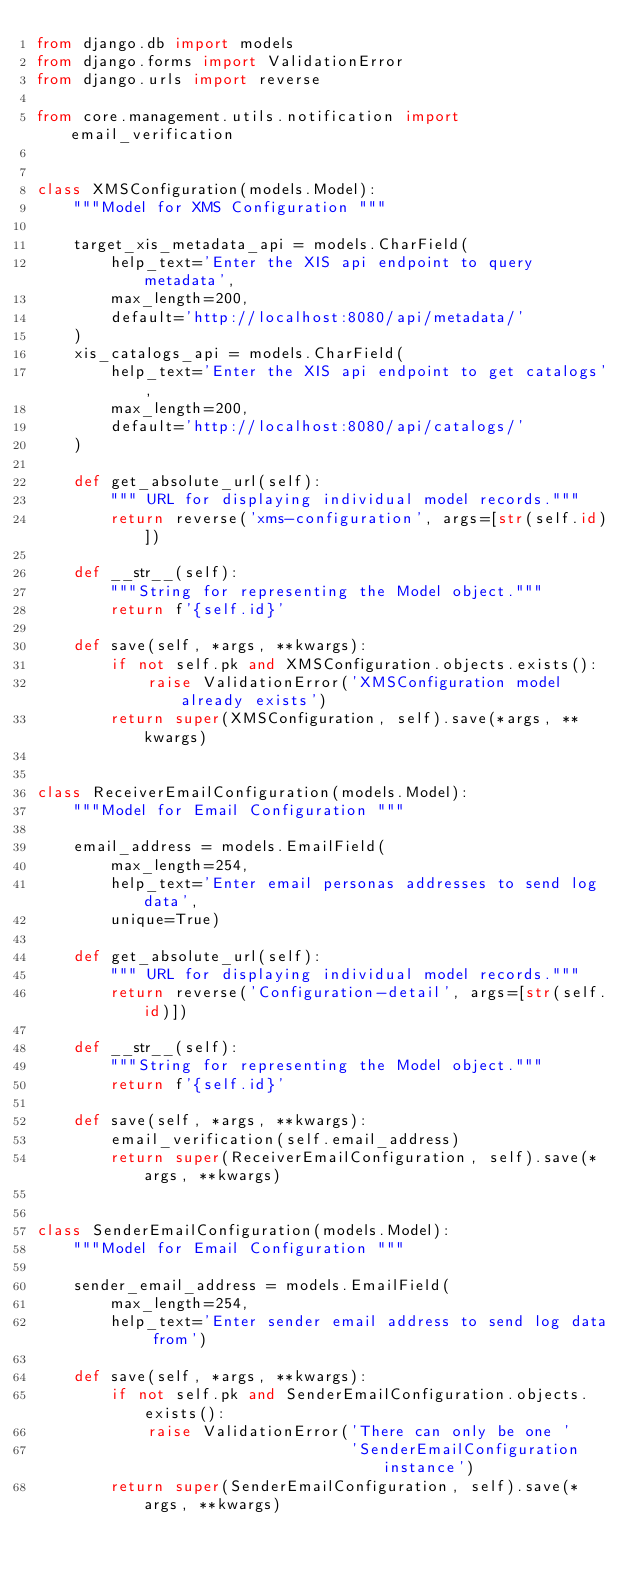Convert code to text. <code><loc_0><loc_0><loc_500><loc_500><_Python_>from django.db import models
from django.forms import ValidationError
from django.urls import reverse

from core.management.utils.notification import email_verification


class XMSConfiguration(models.Model):
    """Model for XMS Configuration """

    target_xis_metadata_api = models.CharField(
        help_text='Enter the XIS api endpoint to query metadata',
        max_length=200,
        default='http://localhost:8080/api/metadata/'
    )
    xis_catalogs_api = models.CharField(
        help_text='Enter the XIS api endpoint to get catalogs',
        max_length=200,
        default='http://localhost:8080/api/catalogs/'
    )

    def get_absolute_url(self):
        """ URL for displaying individual model records."""
        return reverse('xms-configuration', args=[str(self.id)])

    def __str__(self):
        """String for representing the Model object."""
        return f'{self.id}'

    def save(self, *args, **kwargs):
        if not self.pk and XMSConfiguration.objects.exists():
            raise ValidationError('XMSConfiguration model already exists')
        return super(XMSConfiguration, self).save(*args, **kwargs)


class ReceiverEmailConfiguration(models.Model):
    """Model for Email Configuration """

    email_address = models.EmailField(
        max_length=254,
        help_text='Enter email personas addresses to send log data',
        unique=True)

    def get_absolute_url(self):
        """ URL for displaying individual model records."""
        return reverse('Configuration-detail', args=[str(self.id)])

    def __str__(self):
        """String for representing the Model object."""
        return f'{self.id}'

    def save(self, *args, **kwargs):
        email_verification(self.email_address)
        return super(ReceiverEmailConfiguration, self).save(*args, **kwargs)


class SenderEmailConfiguration(models.Model):
    """Model for Email Configuration """

    sender_email_address = models.EmailField(
        max_length=254,
        help_text='Enter sender email address to send log data from')

    def save(self, *args, **kwargs):
        if not self.pk and SenderEmailConfiguration.objects.exists():
            raise ValidationError('There can only be one '
                                  'SenderEmailConfiguration instance')
        return super(SenderEmailConfiguration, self).save(*args, **kwargs)
</code> 